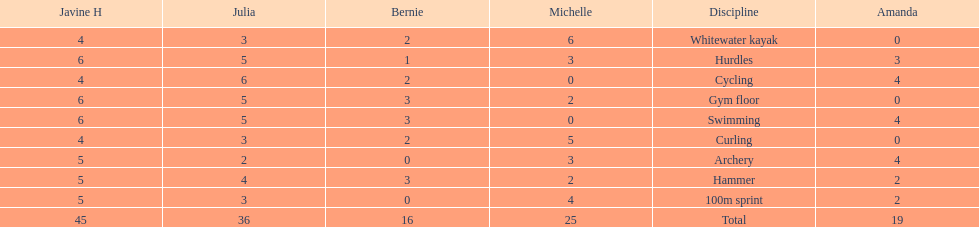What is the last discipline listed on this chart? 100m sprint. 